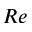Convert formula to latex. <formula><loc_0><loc_0><loc_500><loc_500>R e</formula> 